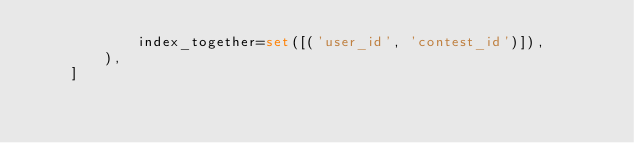<code> <loc_0><loc_0><loc_500><loc_500><_Python_>            index_together=set([('user_id', 'contest_id')]),
        ),
    ]
</code> 